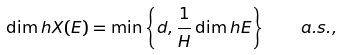<formula> <loc_0><loc_0><loc_500><loc_500>\dim h X ( E ) = \min \left \{ d , \frac { 1 } { H } \dim h E \right \} \quad a . s . ,</formula> 